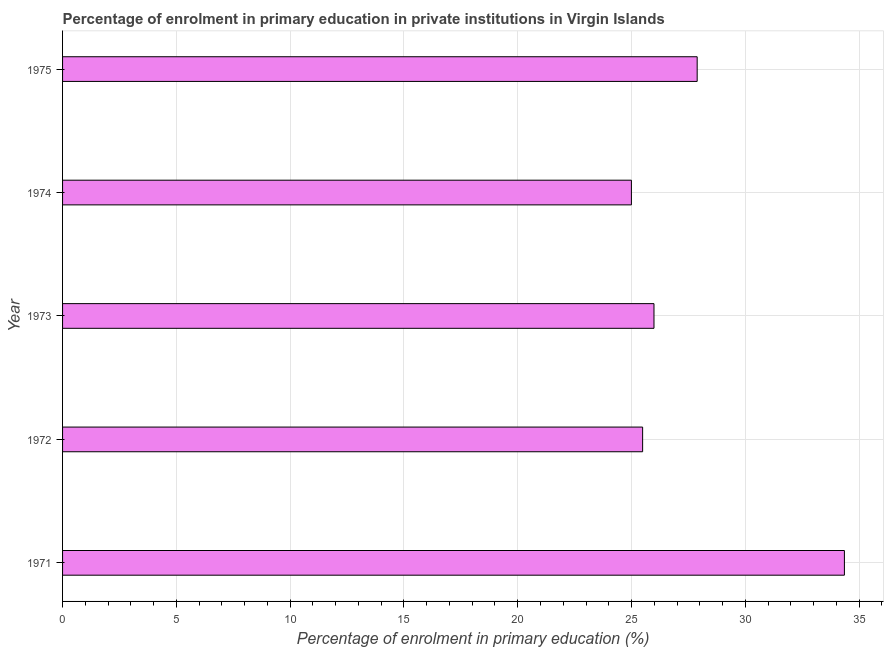Does the graph contain grids?
Your response must be concise. Yes. What is the title of the graph?
Keep it short and to the point. Percentage of enrolment in primary education in private institutions in Virgin Islands. What is the label or title of the X-axis?
Offer a terse response. Percentage of enrolment in primary education (%). What is the label or title of the Y-axis?
Offer a terse response. Year. What is the enrolment percentage in primary education in 1975?
Provide a succinct answer. 27.88. Across all years, what is the maximum enrolment percentage in primary education?
Offer a very short reply. 34.35. Across all years, what is the minimum enrolment percentage in primary education?
Provide a short and direct response. 24.99. In which year was the enrolment percentage in primary education maximum?
Give a very brief answer. 1971. In which year was the enrolment percentage in primary education minimum?
Make the answer very short. 1974. What is the sum of the enrolment percentage in primary education?
Make the answer very short. 138.7. What is the difference between the enrolment percentage in primary education in 1972 and 1974?
Make the answer very short. 0.49. What is the average enrolment percentage in primary education per year?
Your answer should be very brief. 27.74. What is the median enrolment percentage in primary education?
Make the answer very short. 25.99. What is the ratio of the enrolment percentage in primary education in 1971 to that in 1972?
Your response must be concise. 1.35. Is the enrolment percentage in primary education in 1971 less than that in 1973?
Your answer should be very brief. No. Is the difference between the enrolment percentage in primary education in 1974 and 1975 greater than the difference between any two years?
Your answer should be compact. No. What is the difference between the highest and the second highest enrolment percentage in primary education?
Make the answer very short. 6.47. Is the sum of the enrolment percentage in primary education in 1971 and 1974 greater than the maximum enrolment percentage in primary education across all years?
Keep it short and to the point. Yes. What is the difference between the highest and the lowest enrolment percentage in primary education?
Offer a very short reply. 9.36. How many bars are there?
Offer a terse response. 5. Are all the bars in the graph horizontal?
Ensure brevity in your answer.  Yes. How many years are there in the graph?
Make the answer very short. 5. Are the values on the major ticks of X-axis written in scientific E-notation?
Offer a terse response. No. What is the Percentage of enrolment in primary education (%) in 1971?
Offer a terse response. 34.35. What is the Percentage of enrolment in primary education (%) of 1972?
Your answer should be compact. 25.49. What is the Percentage of enrolment in primary education (%) in 1973?
Ensure brevity in your answer.  25.99. What is the Percentage of enrolment in primary education (%) in 1974?
Your answer should be very brief. 24.99. What is the Percentage of enrolment in primary education (%) of 1975?
Offer a very short reply. 27.88. What is the difference between the Percentage of enrolment in primary education (%) in 1971 and 1972?
Your answer should be compact. 8.87. What is the difference between the Percentage of enrolment in primary education (%) in 1971 and 1973?
Make the answer very short. 8.37. What is the difference between the Percentage of enrolment in primary education (%) in 1971 and 1974?
Make the answer very short. 9.36. What is the difference between the Percentage of enrolment in primary education (%) in 1971 and 1975?
Provide a short and direct response. 6.47. What is the difference between the Percentage of enrolment in primary education (%) in 1972 and 1973?
Your response must be concise. -0.5. What is the difference between the Percentage of enrolment in primary education (%) in 1972 and 1974?
Offer a very short reply. 0.49. What is the difference between the Percentage of enrolment in primary education (%) in 1972 and 1975?
Ensure brevity in your answer.  -2.4. What is the difference between the Percentage of enrolment in primary education (%) in 1973 and 1974?
Your response must be concise. 0.99. What is the difference between the Percentage of enrolment in primary education (%) in 1973 and 1975?
Offer a terse response. -1.9. What is the difference between the Percentage of enrolment in primary education (%) in 1974 and 1975?
Keep it short and to the point. -2.89. What is the ratio of the Percentage of enrolment in primary education (%) in 1971 to that in 1972?
Ensure brevity in your answer.  1.35. What is the ratio of the Percentage of enrolment in primary education (%) in 1971 to that in 1973?
Your answer should be compact. 1.32. What is the ratio of the Percentage of enrolment in primary education (%) in 1971 to that in 1974?
Ensure brevity in your answer.  1.37. What is the ratio of the Percentage of enrolment in primary education (%) in 1971 to that in 1975?
Offer a very short reply. 1.23. What is the ratio of the Percentage of enrolment in primary education (%) in 1972 to that in 1973?
Ensure brevity in your answer.  0.98. What is the ratio of the Percentage of enrolment in primary education (%) in 1972 to that in 1975?
Your response must be concise. 0.91. What is the ratio of the Percentage of enrolment in primary education (%) in 1973 to that in 1974?
Keep it short and to the point. 1.04. What is the ratio of the Percentage of enrolment in primary education (%) in 1973 to that in 1975?
Give a very brief answer. 0.93. What is the ratio of the Percentage of enrolment in primary education (%) in 1974 to that in 1975?
Provide a succinct answer. 0.9. 